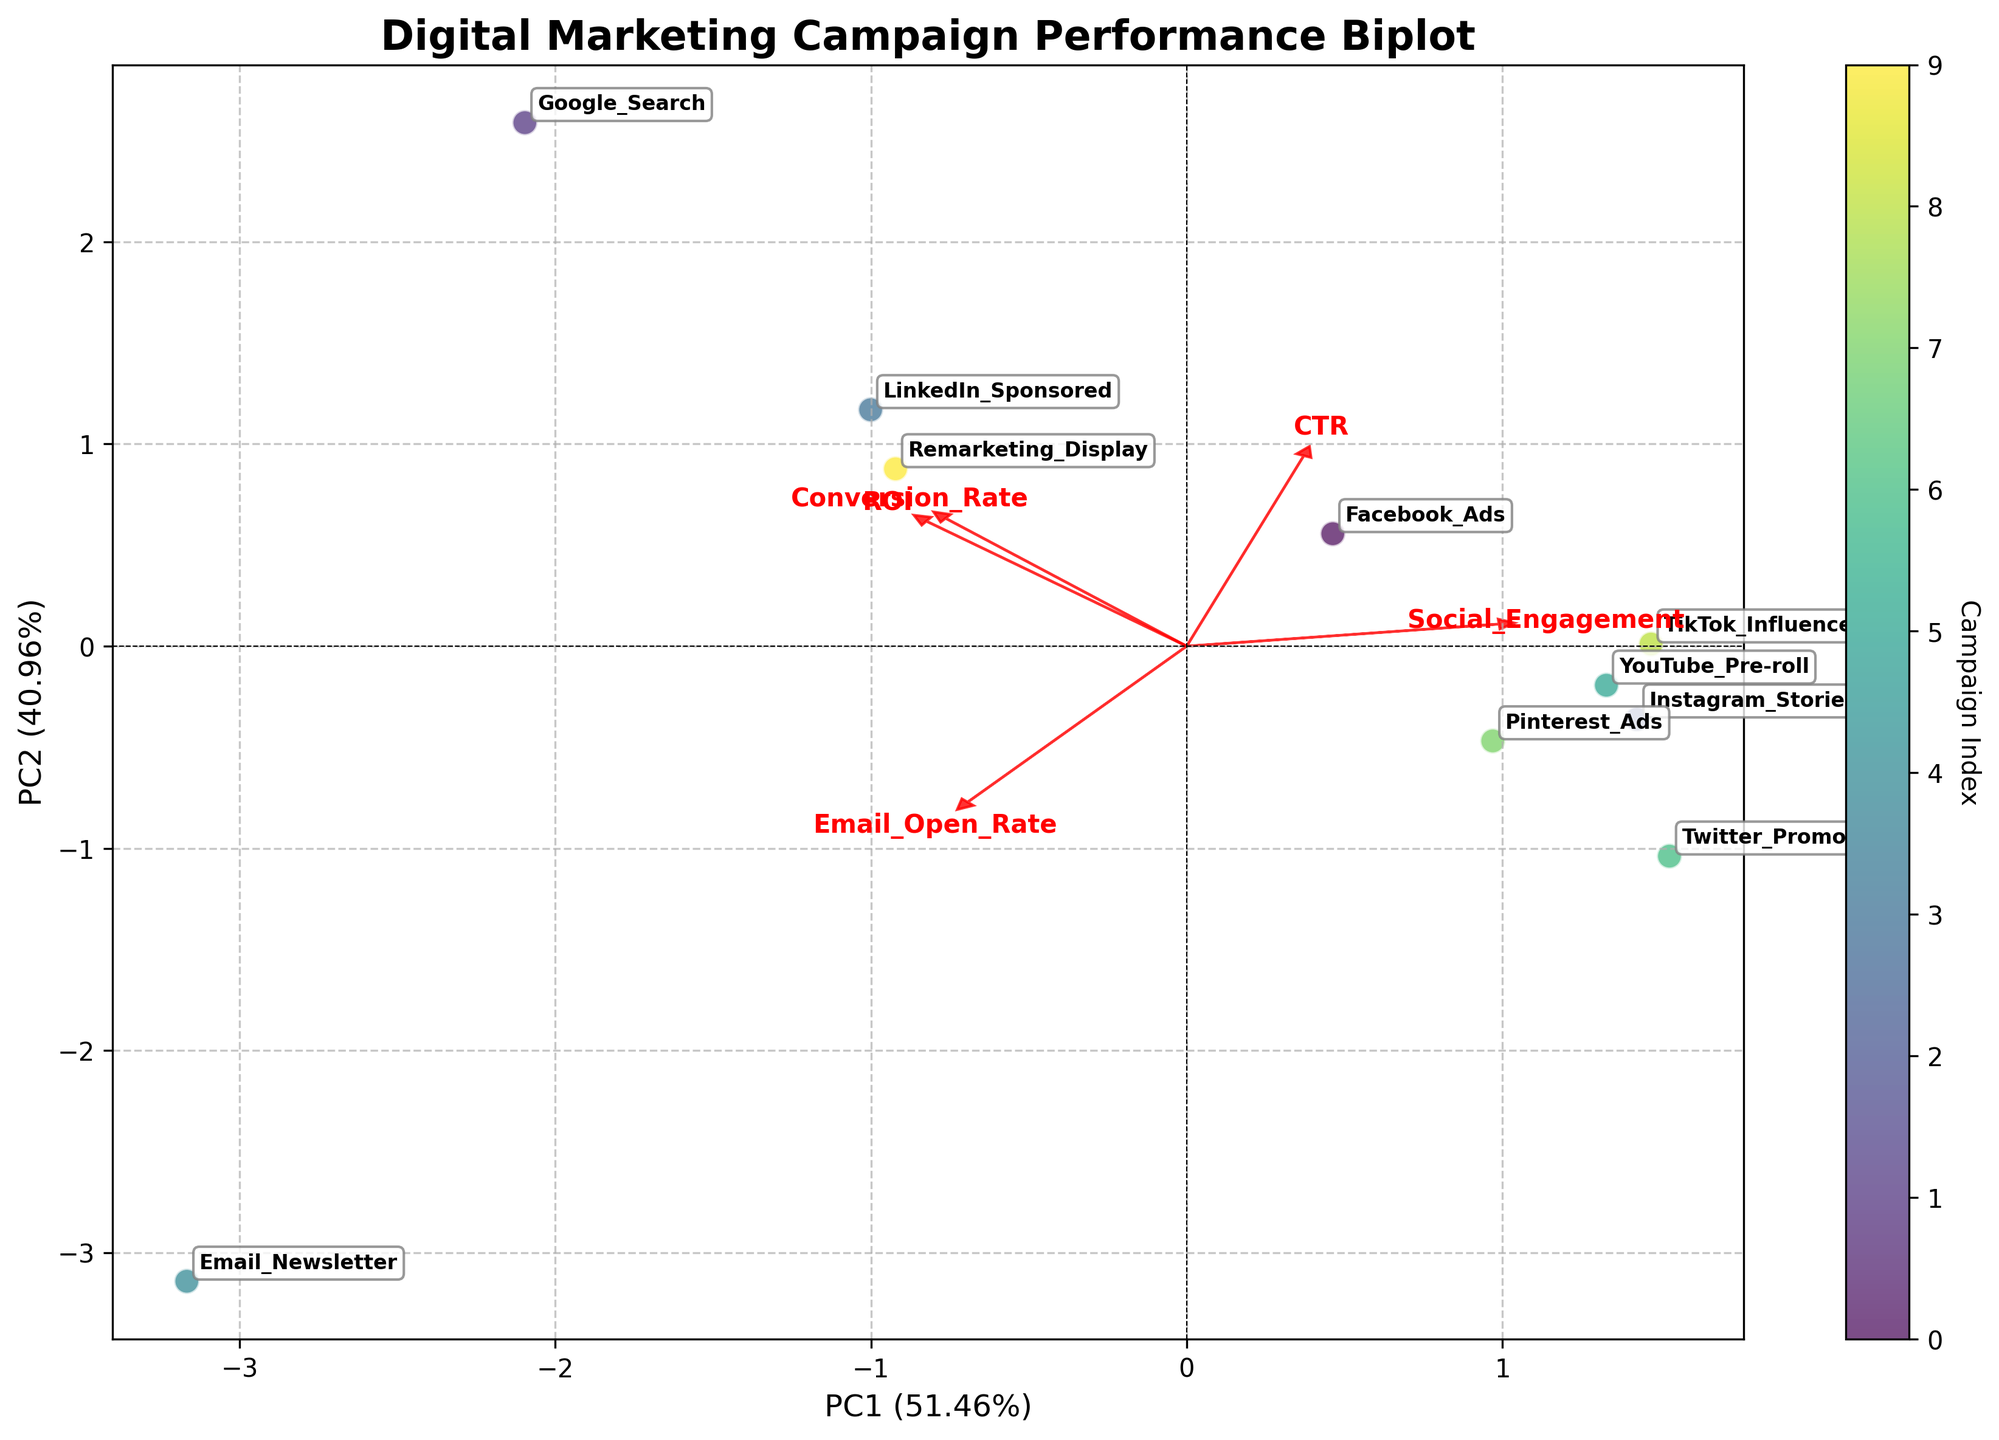What is the title of the plot? The title is usually located at the top of the plot. In this case, it states "Digital Marketing Campaign Performance Biplot".
Answer: Digital Marketing Campaign Performance Biplot How many campaigns are represented in the plot? By counting the number of unique labels annotated on the scatter plot, we can determine the number of campaigns.
Answer: 10 Which campaigns have the highest social engagement? Check which data points are located towards the direction of the 'Social_Engagement' vector in the biplot. The ones further along this vector indicate higher social engagement.
Answer: TikTok_Influencer & Instagram_Stories Which campaign shows the highest Email Open Rate? Email Open Rate can be identified by finding the data point closest to the direction of the 'Email_Open_Rate' vector.
Answer: Email_Newsletter Which campaigns are located close to each other in the plot, suggesting similar performance across the evaluated metrics? By visually inspecting the scatter plot, we can see which campaigns' data points are positioned near each other.
Answer: Facebook_Ads & TikTok_Influencer How do ROI and Conversion Rate relate to each other across campaigns? Observe the directions and angles of the 'ROI' and 'Conversion_Rate' vectors. A small angle suggests these metrics tend to increase together.
Answer: They are closely related What percentage of variance is explained by the first principal component (PC1)? This information can be found on the x-axis label of the plot. It includes the variance percentage explained by PC1.
Answer: 54.2% Which campaign is closest to the origin on the plot? Locate the data point nearest to (0,0) which indicates minimal performance deviation from the average.
Answer: Email_Newsletter Which metric seems to have influenced the second principal component (PC2) the most? Look at the vector directions on the y-axis (PC2). The most influential vector is the one most aligned with the y-axis.
Answer: Social_Engagement 